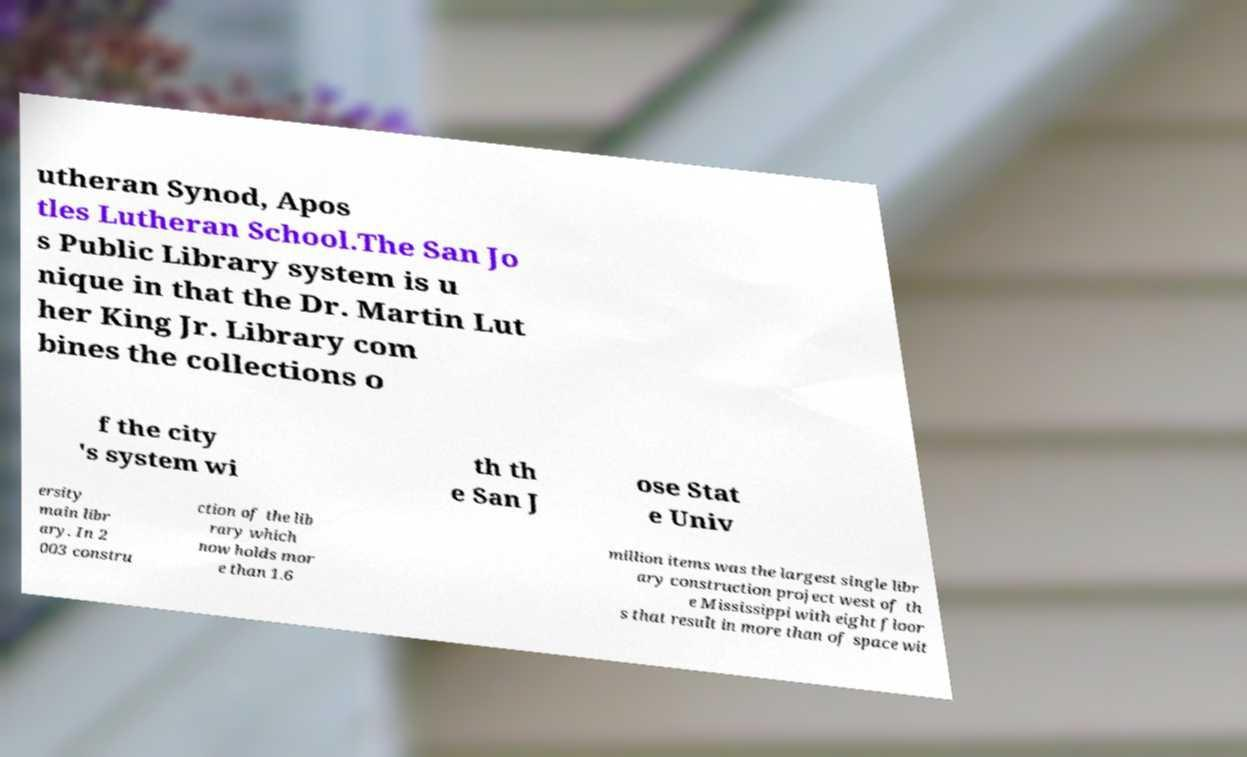Can you accurately transcribe the text from the provided image for me? utheran Synod, Apos tles Lutheran School.The San Jo s Public Library system is u nique in that the Dr. Martin Lut her King Jr. Library com bines the collections o f the city 's system wi th th e San J ose Stat e Univ ersity main libr ary. In 2 003 constru ction of the lib rary which now holds mor e than 1.6 million items was the largest single libr ary construction project west of th e Mississippi with eight floor s that result in more than of space wit 